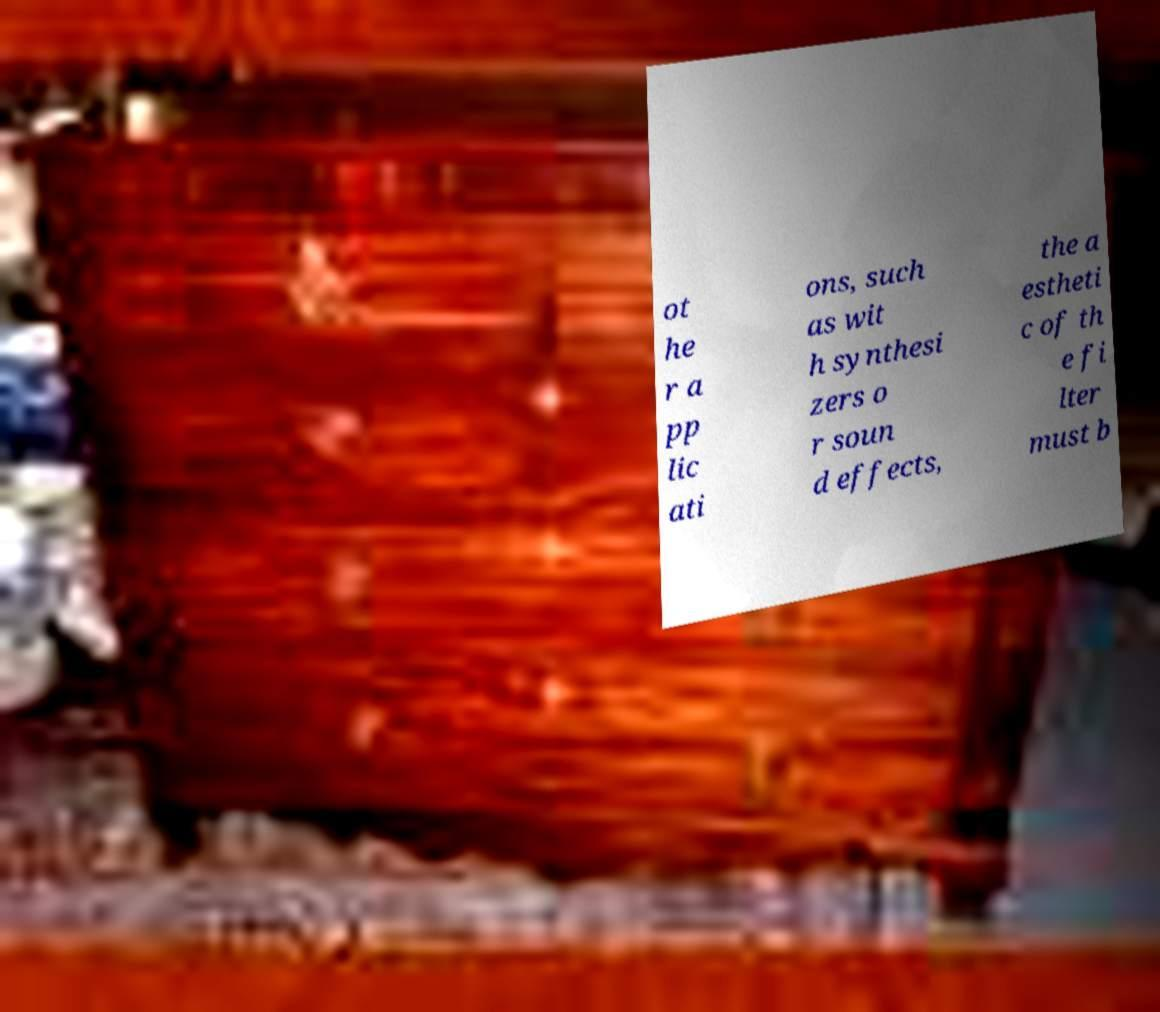For documentation purposes, I need the text within this image transcribed. Could you provide that? ot he r a pp lic ati ons, such as wit h synthesi zers o r soun d effects, the a estheti c of th e fi lter must b 